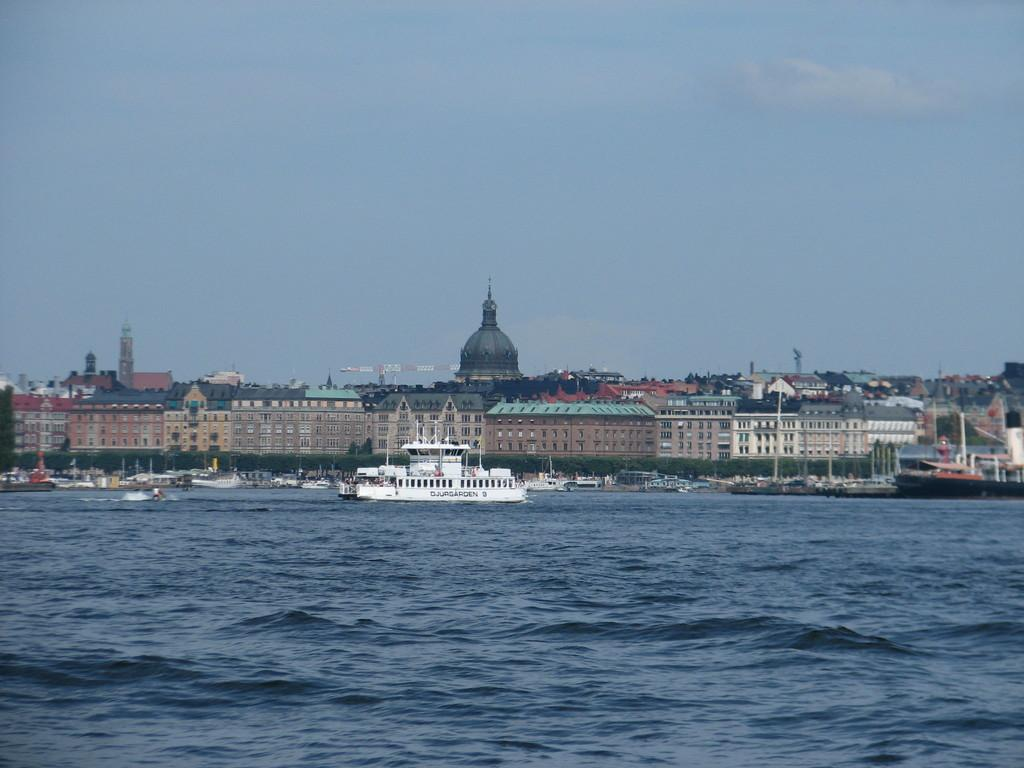What is the primary element in the image? There is water in the image. What can be seen floating on the water? There are boats in the image. What type of vegetation is visible in the image? There are trees in the image. What type of structures can be seen in the image? There are buildings in the image. What is visible in the background of the image? The sky is visible in the background of the image. What type of protest is taking place near the seashore in the image? There is no protest or seashore present in the image; it features water, boats, trees, buildings, and the sky. Can you see a pipe running through the water in the image? There is no pipe visible in the image; it only features water, boats, trees, buildings, and the sky. 